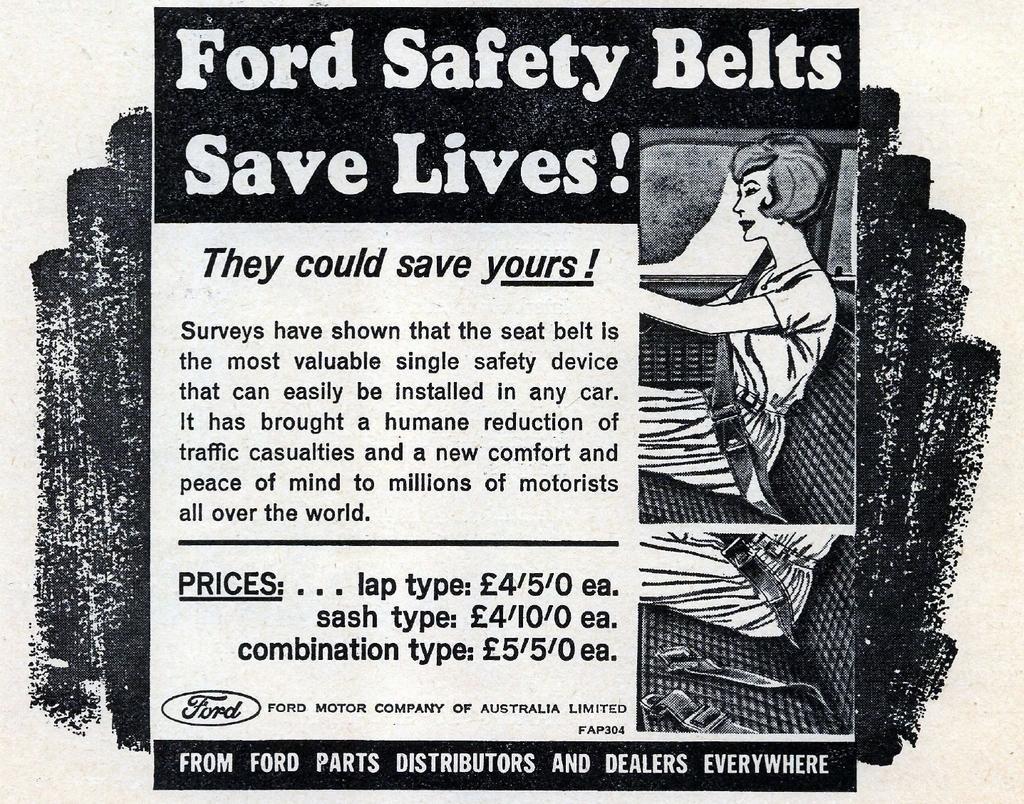Can you describe this image briefly? This image is like a poster. On the right side of the image a lady is sitting. In the background of the image we can see some text. 